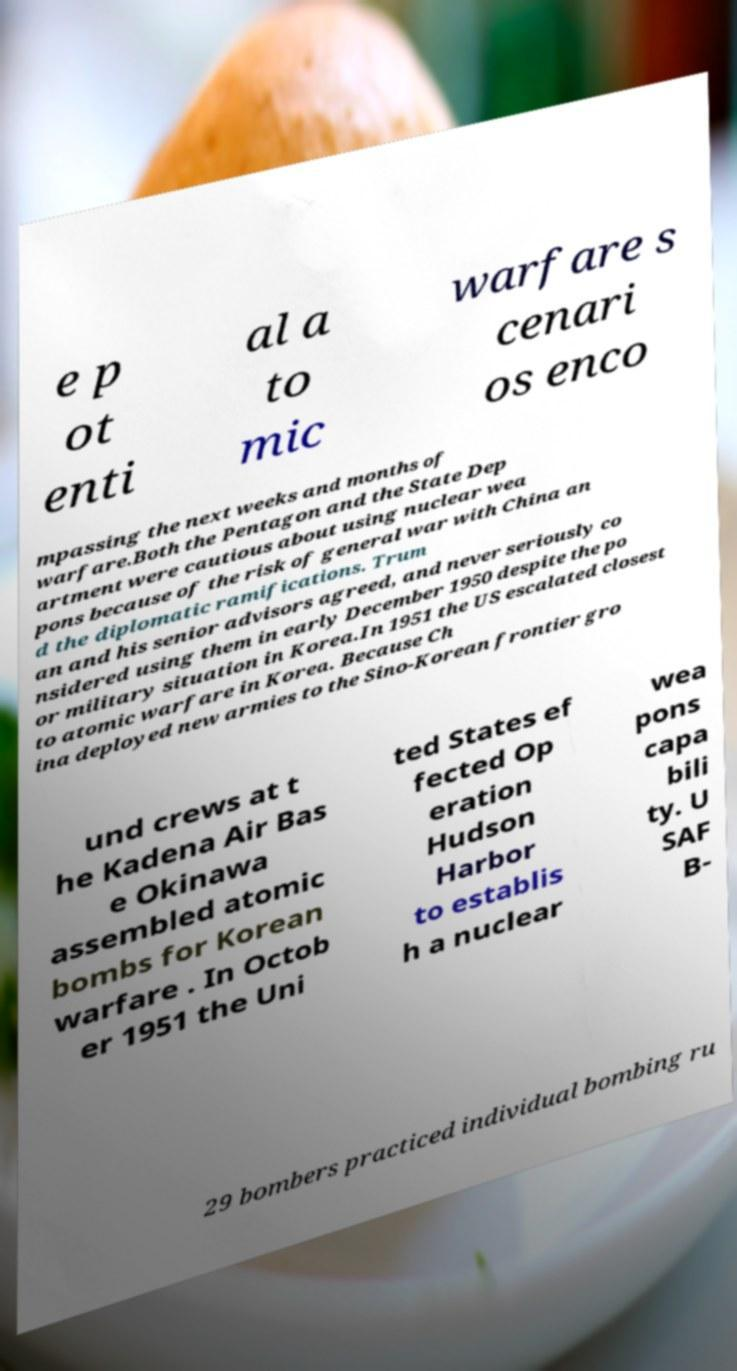Could you assist in decoding the text presented in this image and type it out clearly? e p ot enti al a to mic warfare s cenari os enco mpassing the next weeks and months of warfare.Both the Pentagon and the State Dep artment were cautious about using nuclear wea pons because of the risk of general war with China an d the diplomatic ramifications. Trum an and his senior advisors agreed, and never seriously co nsidered using them in early December 1950 despite the po or military situation in Korea.In 1951 the US escalated closest to atomic warfare in Korea. Because Ch ina deployed new armies to the Sino-Korean frontier gro und crews at t he Kadena Air Bas e Okinawa assembled atomic bombs for Korean warfare . In Octob er 1951 the Uni ted States ef fected Op eration Hudson Harbor to establis h a nuclear wea pons capa bili ty. U SAF B- 29 bombers practiced individual bombing ru 